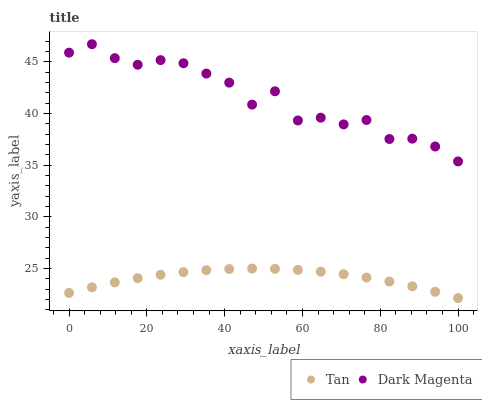Does Tan have the minimum area under the curve?
Answer yes or no. Yes. Does Dark Magenta have the maximum area under the curve?
Answer yes or no. Yes. Does Dark Magenta have the minimum area under the curve?
Answer yes or no. No. Is Tan the smoothest?
Answer yes or no. Yes. Is Dark Magenta the roughest?
Answer yes or no. Yes. Is Dark Magenta the smoothest?
Answer yes or no. No. Does Tan have the lowest value?
Answer yes or no. Yes. Does Dark Magenta have the lowest value?
Answer yes or no. No. Does Dark Magenta have the highest value?
Answer yes or no. Yes. Is Tan less than Dark Magenta?
Answer yes or no. Yes. Is Dark Magenta greater than Tan?
Answer yes or no. Yes. Does Tan intersect Dark Magenta?
Answer yes or no. No. 